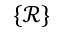Convert formula to latex. <formula><loc_0><loc_0><loc_500><loc_500>\{ \mathcal { R } \}</formula> 